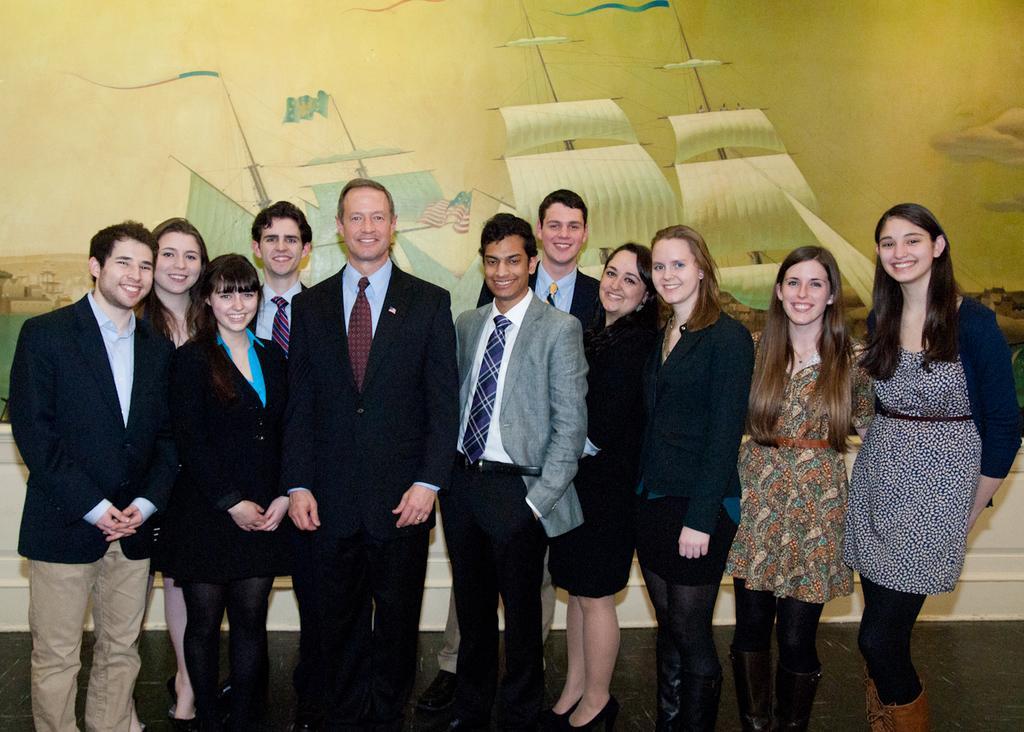How would you summarize this image in a sentence or two? In this image, I can see a group of people standing on the floor and smiling. In the background, there is a poster on the wall. 